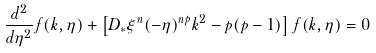Convert formula to latex. <formula><loc_0><loc_0><loc_500><loc_500>\frac { d ^ { 2 } } { d \eta ^ { 2 } } f ( k , \eta ) + \left [ D _ { * } \xi ^ { n } ( - \eta ) ^ { n p } k ^ { 2 } - p ( p - 1 ) \right ] f ( k , \eta ) = 0</formula> 